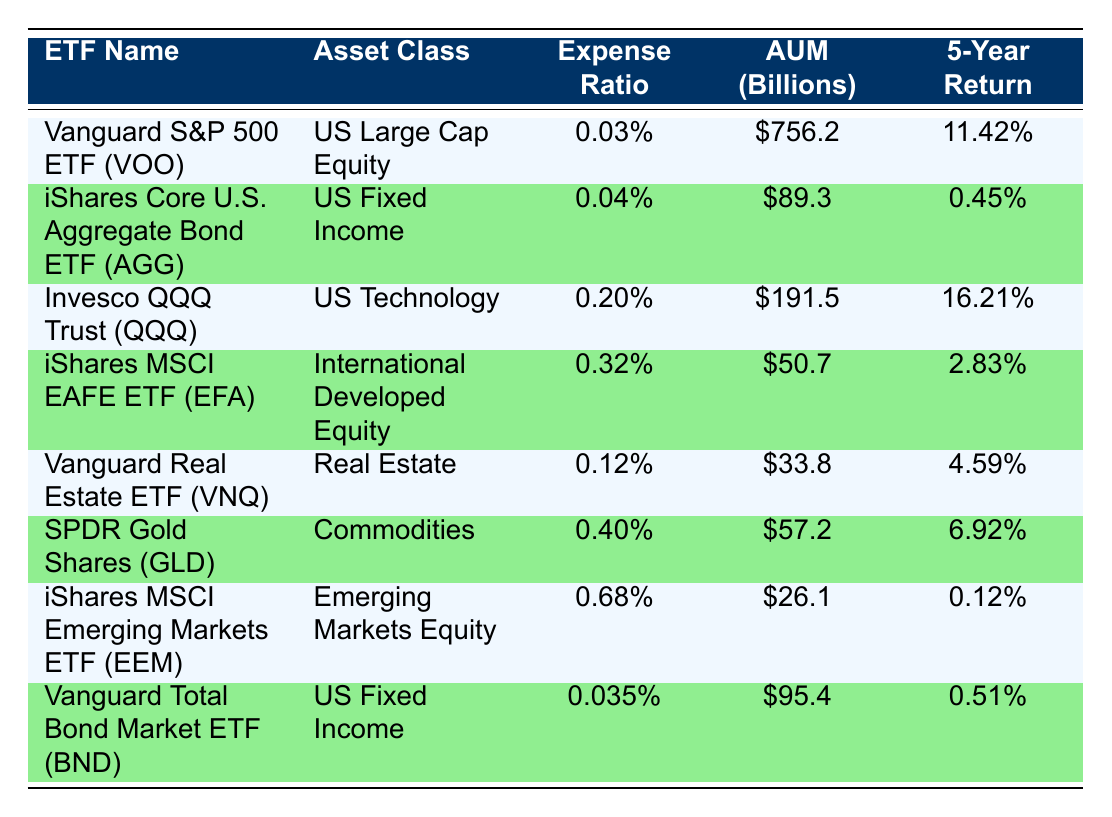What is the Expense Ratio of the Vanguard S&P 500 ETF (VOO)? The table lists the Vanguard S&P 500 ETF (VOO) under the "ETF Name" column, and the corresponding "Expense Ratio" is directly provided as 0.03%.
Answer: 0.03% Which asset class has the highest 5-Year Return? By examining the "5-Year Return" column, the highest value is 16.21% associated with the Invesco QQQ Trust (QQQ).
Answer: US Technology Is the Expense Ratio of the iShares MSCI EAFE ETF (EFA) more than that of the Vanguard Real Estate ETF (VNQ)? The Expense Ratio for the iShares MSCI EAFE ETF (EFA) is 0.32% and for the Vanguard Real Estate ETF (VNQ) is 0.12%. Since 0.32% is greater than 0.12%, the answer is yes.
Answer: Yes What is the average 5-Year Return of all US Fixed Income ETFs? The US Fixed Income ETFs are iShares Core U.S. Aggregate Bond ETF (AGG) with a 5-Year Return of 0.45% and Vanguard Total Bond Market ETF (BND) with a 5-Year Return of 0.51%. The average is (0.45% + 0.51%) / 2 = 0.48%.
Answer: 0.48% Which ETF has the lowest Expense Ratio and what is it? From the "Expense Ratio" column, the lowest value is 0.035% for the Vanguard Total Bond Market ETF (BND).
Answer: Vanguard Total Bond Market ETF (BND) - 0.035% What is the total AUM of all the ETFs listed in the table? The AUMs provided in the table are: 756.2, 89.3, 191.5, 50.7, 33.8, 57.2, 26.1, and 95.4 (in billions). Adding these together gives a total AUM of 1200.2 billion.
Answer: 1200.2 billion Does the SPDR Gold Shares (GLD) ETF have a higher 5-Year Return than the iShares MSCI Emerging Markets ETF (EEM)? The 5-Year Return for SPDR Gold Shares (GLD) is 6.92% while for iShares MSCI Emerging Markets ETF (EEM) it is 0.12%. Since 6.92% is greater than 0.12%, the answer is yes.
Answer: Yes What is the difference in Expense Ratios between the Invesco QQQ Trust (QQQ) and Vanguard S&P 500 ETF (VOO)? The Expense Ratio for QQQ is 0.20% and for VOO is 0.03%. The difference is 0.20% - 0.03% = 0.17%.
Answer: 0.17% 